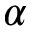Convert formula to latex. <formula><loc_0><loc_0><loc_500><loc_500>\alpha</formula> 